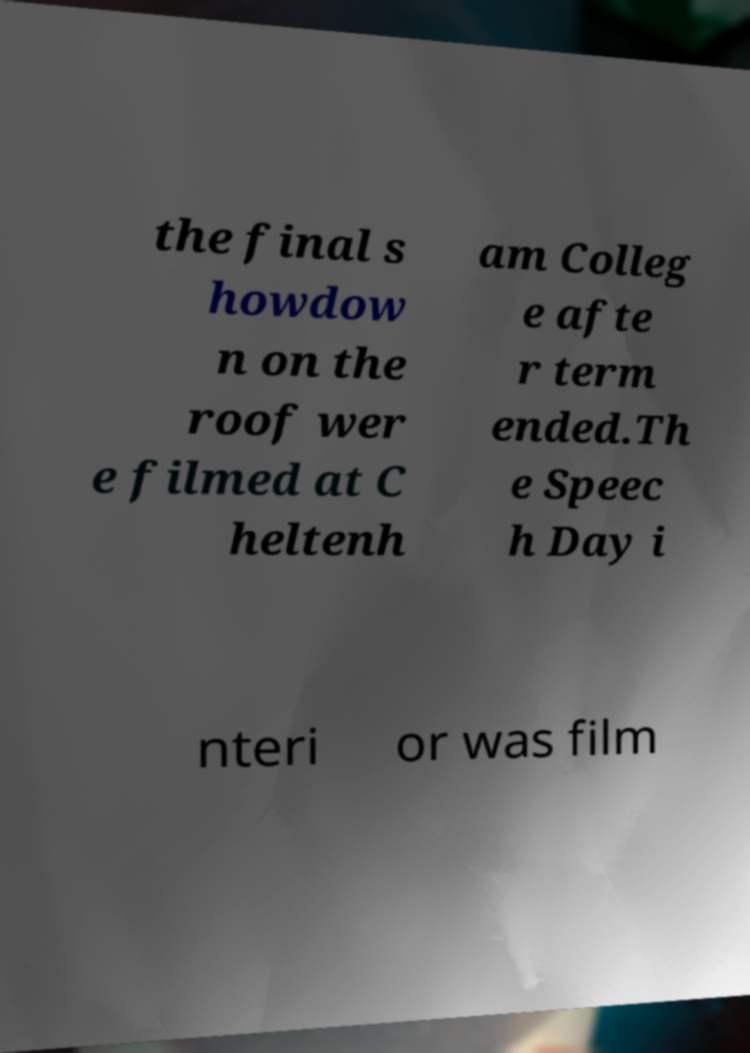I need the written content from this picture converted into text. Can you do that? the final s howdow n on the roof wer e filmed at C heltenh am Colleg e afte r term ended.Th e Speec h Day i nteri or was film 